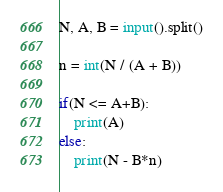<code> <loc_0><loc_0><loc_500><loc_500><_Python_>N, A, B = input().split()

n = int(N / (A + B))

if(N <= A+B):
    print(A)
else:
    print(N - B*n)</code> 